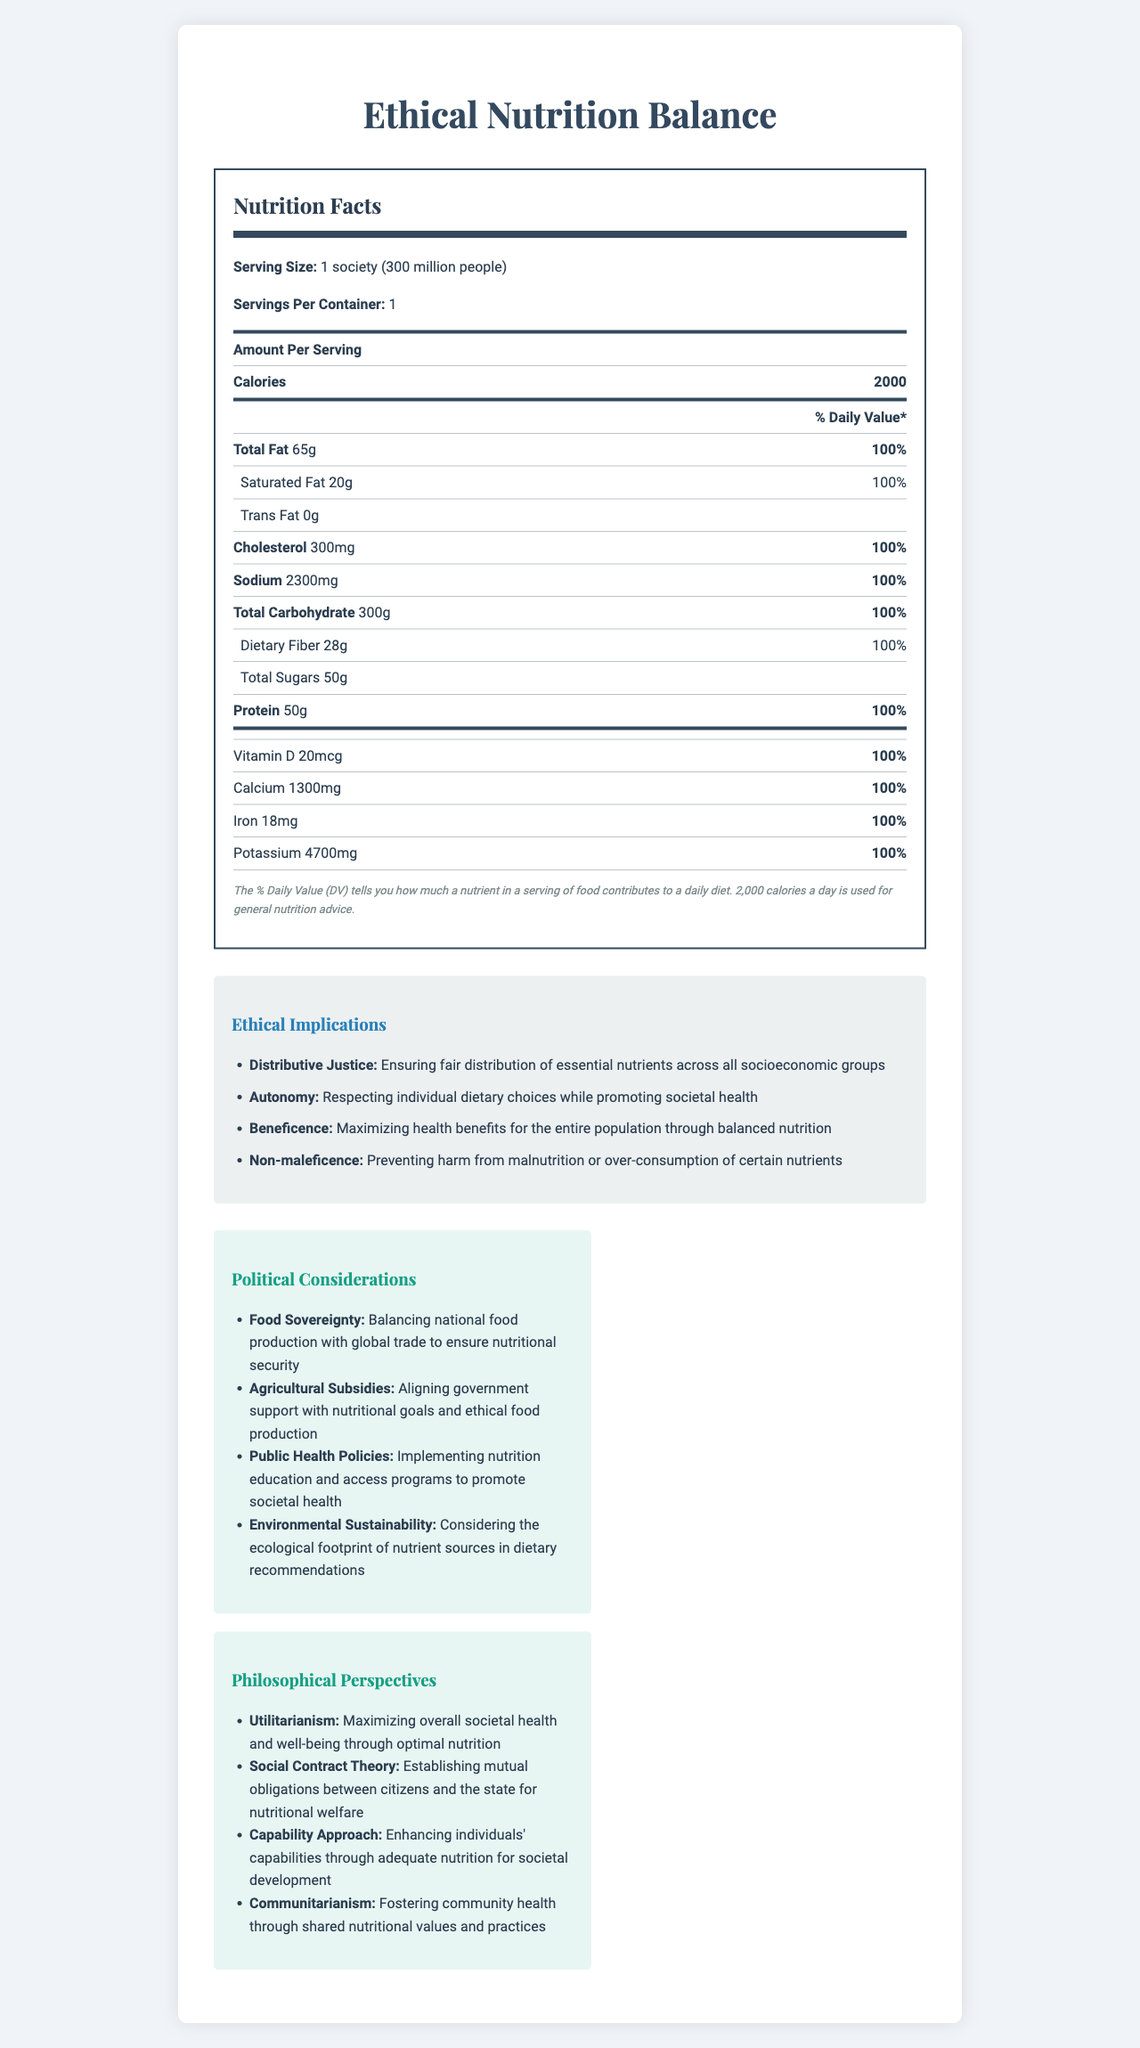what is the serving size for "Ethical Nutrition Balance"? The serving size is explicitly mentioned as "1 society (300 million people)" in the Nutrition Facts.
Answer: 1 society (300 million people) how much total fat is present per serving? The document states that the amount of Total Fat per serving is 65g.
Answer: 65g what is the daily value percentage for sodium? The document indicates that the daily value (DV) for sodium is 100%.
Answer: 100% which nutrient has a daily value of 100% for its sub-item? A. Trans Fat B. Cholesterol C. Dietary Fiber The sub-item of Dietary Fiber has a daily value of 100%, while Trans Fat and Cholesterol have different DV values.
Answer: C how would you describe the principle of distributive justice in the context of this nutrition label? The principle of Distributive Justice is described as ensuring fair distribution of essential nutrients across all socioeconomic groups.
Answer: Ensuring fair distribution of essential nutrients across all socioeconomic groups does the product "Ethical Nutrition Balance" list any amount for Trans Fat? The label indicates that the amount of Trans Fat is 0g.
Answer: Yes summarize the main idea of the document. The document includes detailed nutrition information, ethical implications, political considerations, and philosophical perspectives, all centered on optimizing nutrition for societal well-being.
Answer: The document provides a comprehensive Nutrition Facts Label for a theoretical product named "Ethical Nutrition Balance," intended for a society of 300 million people. It also discusses ethical principles, political considerations, and philosophical perspectives related to nutrition distribution for societal health. what is the total amount of dietary fiber per serving? The document specifies that the amount of Dietary Fiber per serving is 28g.
Answer: 28g in the list of ethical implications, which principle focuses on respecting individual dietary choices? The principle of Autonomy is described as respecting individual dietary choices while promoting societal health.
Answer: Autonomy what is the impact of agricultural subsidies according to the document? The document mentions that agricultural subsidies impact aligning government support with nutritional goals and ethical food production.
Answer: Aligning government support with nutritional goals and ethical food production which philosophical theory is applied to maximizing overall societal health and well-being? A. Utilitarianism B. Social Contract Theory C. Capability Approach Utilitarianism is applied to maximizing overall societal health and well-being through optimal nutrition.
Answer: A how much iron is contained in each serving? The document specifies that each serving contains 18mg of Iron.
Answer: 18mg can you determine the exact amount of total sugars that contributes to the daily value? The document lists the total sugars as 50g but does not specify its percentage of the daily value.
Answer: Not enough information what is one political consideration for environmental sustainability? The document outlines that environmental sustainability involves considering the ecological footprint of nutrient sources in dietary recommendations.
Answer: Considering the ecological footprint of nutrient sources in dietary recommendations is it true that the document addresses issues related to public health policies? The document discusses public health policies, specifically their role in implementing nutrition education and access programs to promote societal health.
Answer: Yes what are some of the nutrients included in the vitamin and mineral section? The document contains a section listing vitamins and minerals, specifically highlighting Vitamin D, Calcium, Iron, and Potassium.
Answer: Vitamin D, Calcium, Iron, Potassium how many principles of ethical implications are listed in the document? The document outlines four ethical principles: Distributive Justice, Autonomy, Beneficence, and Non-maleficence.
Answer: Four 